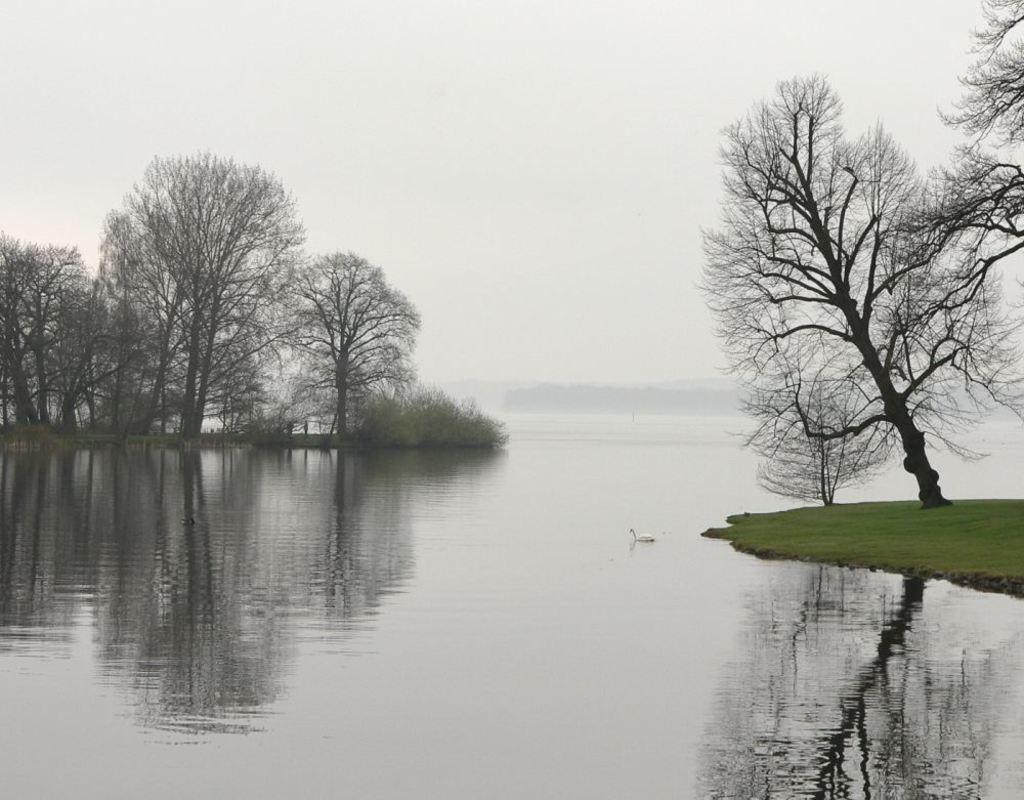What type of animal can be seen in the image? There is a bird in the image. What type of vegetation is present in the image? There is grass in the image. What else can be seen in the image besides the bird and grass? There is water and trees in the image. What is visible in the background of the image? The sky is visible in the background of the image. What type of jelly is being used to write a message on the bird in the image? There is no jelly or writing present in the image; it features a bird in a natural setting with grass, water, and trees. 